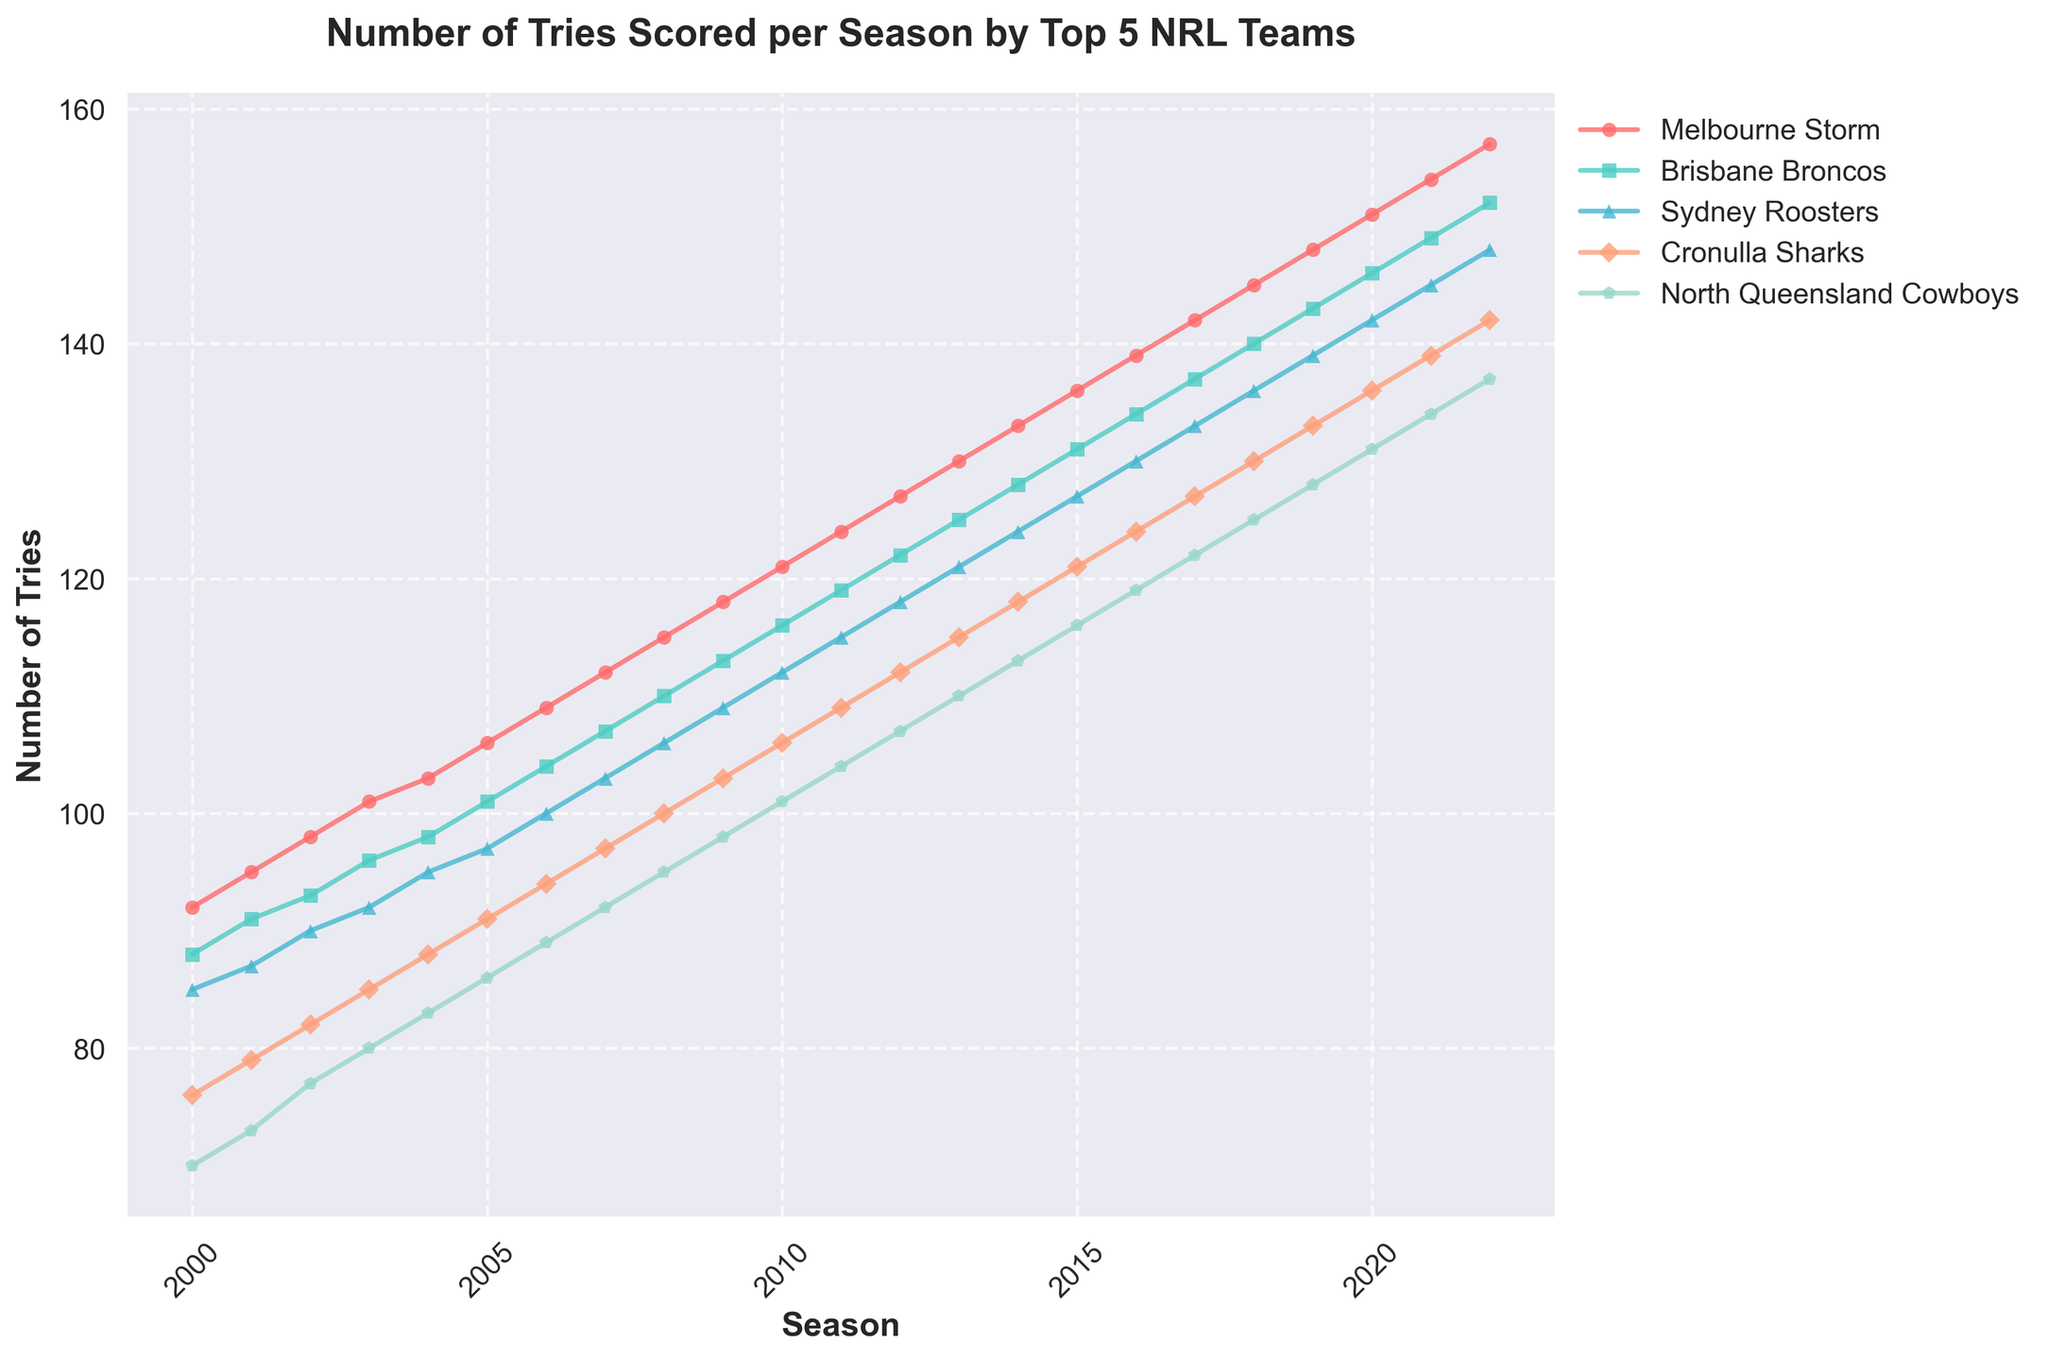Which team scored the most tries in 2022? To find the answer, check the graph for the data points for 2022. The Melbourne Storm has the highest value.
Answer: Melbourne Storm Which seasons show an intersection between the Brisbane Broncos and the Sydney Roosters' number of tries? Identify lines where they intersect. The figure shows an intersection at the 2022 season.
Answer: 2022 What is the difference in the number of tries scored by the North Queensland Cowboys between 2000 and 2022? Look at the tries scored by the North Queensland Cowboys in 2000 and 2022. In 2000 the value is 70, and in 2022 it is 137. The difference is 137 - 70 = 67.
Answer: 67 From 2000 to 2010, which team had the highest average number of tries per season? Calculate the average tries for each team from 2000 to 2010. Melbourne Storm has the highest average as their line is primarily above the others.
Answer: Melbourne Storm By how many tries did Melbourne Storm's score increase from 2000 to 2022? Look at Melbourne Storm’s values at 2000 and 2022. The values are 92 in 2000 and 157 in 2022. The increase is 157 - 92 = 65.
Answer: 65 Which team had the least number of tries in 2019? Look at the data points for 2019. The least value corresponds to the North Queensland Cowboys.
Answer: North Queensland Cowboys What is the trend of the number of tries scored by the Cronulla Sharks from 2000 to 2022? Observe the line for the Cronulla Sharks over the years. The line consistently rises, indicating an increasing trend in the number of tries.
Answer: Increasing In which season did the Sydney Roosters surpass 100 tries for the first time? Look at the Sydney Roosters' data points and find when it first exceeds 100. It occurs in 2007 when they have 103 tries.
Answer: 2007 What is the visual difference between the markers used for Brisbane Broncos and North Queensland Cowboys? Identify the markers for both teams. Brisbane Broncos use a square marker, and North Queensland Cowboys use a pentagon marker.
Answer: Square and pentagon If we sum the number of tries scored by all five teams in 2010, what is the total? Add the tries for all teams in 2010: 121 (Melbourne Storm) + 116 (Brisbane Broncos) + 112 (Sydney Roosters) + 106 (Cronulla Sharks) + 101 (North Queensland Cowboys) = 556
Answer: 556 